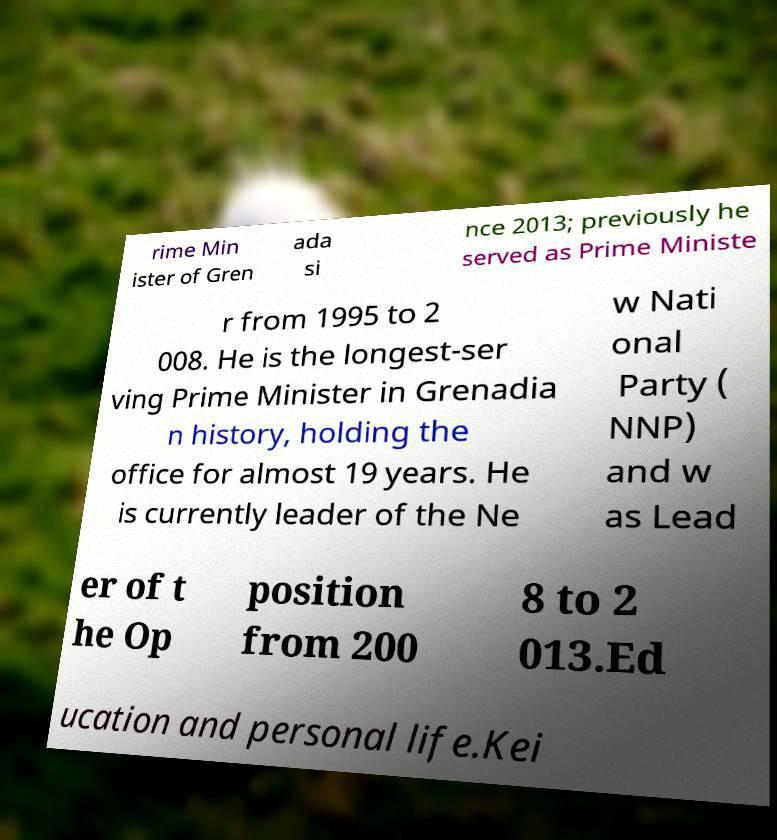Could you extract and type out the text from this image? rime Min ister of Gren ada si nce 2013; previously he served as Prime Ministe r from 1995 to 2 008. He is the longest-ser ving Prime Minister in Grenadia n history, holding the office for almost 19 years. He is currently leader of the Ne w Nati onal Party ( NNP) and w as Lead er of t he Op position from 200 8 to 2 013.Ed ucation and personal life.Kei 